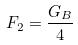<formula> <loc_0><loc_0><loc_500><loc_500>F _ { 2 } = \frac { G _ { B } } { 4 }</formula> 